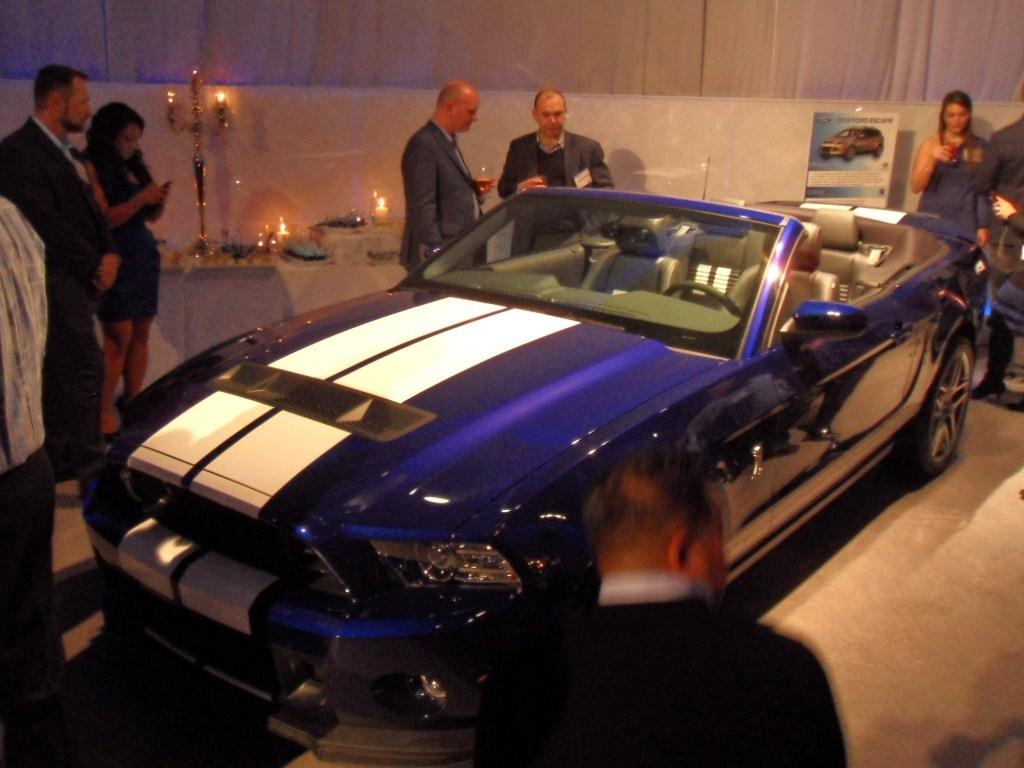What are the people in the image doing? The persons in the image are standing beside a car. What color is the car? The car is colored blue. Can you describe any additional objects or features in the image? There is a candle light in the top left of the image. How does the brother interact with the patch during the rainstorm in the image? There is no brother or rainstorm present in the image; it features persons standing beside a blue car and a candle light. 